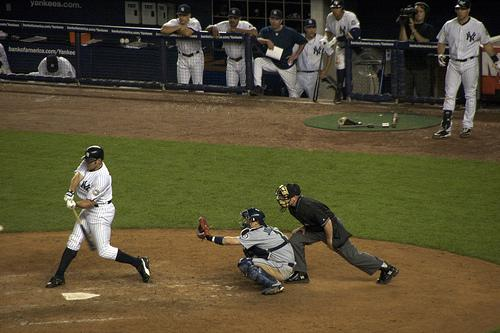Why does the kneeling man crouch low? Please explain your reasoning. catch ball. The man is the catcher and the ball is thrown low. 